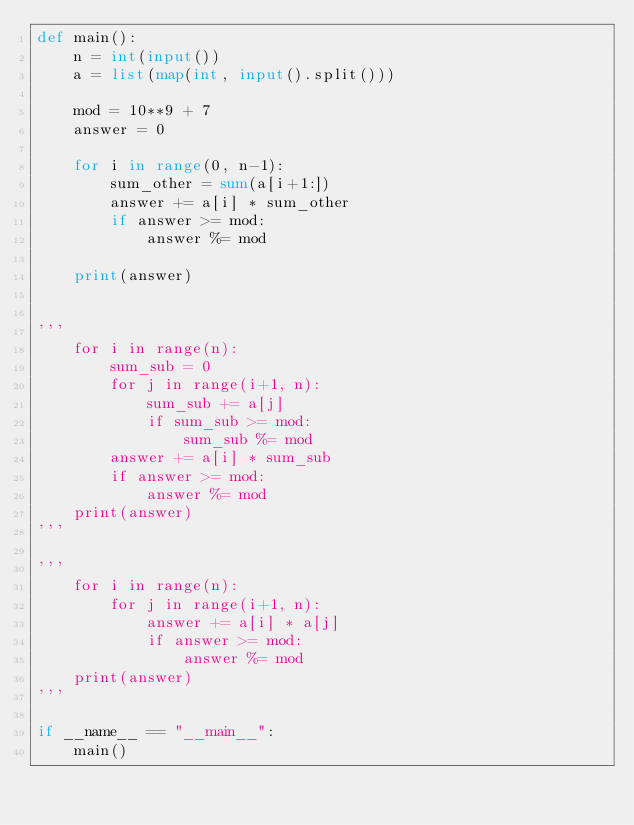Convert code to text. <code><loc_0><loc_0><loc_500><loc_500><_Python_>def main():
    n = int(input())
    a = list(map(int, input().split()))

    mod = 10**9 + 7
    answer = 0

    for i in range(0, n-1):
        sum_other = sum(a[i+1:])
        answer += a[i] * sum_other
        if answer >= mod:
            answer %= mod

    print(answer)


'''
    for i in range(n):
        sum_sub = 0
        for j in range(i+1, n):
            sum_sub += a[j]
            if sum_sub >= mod:
                sum_sub %= mod
        answer += a[i] * sum_sub
        if answer >= mod:
            answer %= mod
    print(answer)
'''

'''
    for i in range(n):
        for j in range(i+1, n):
            answer += a[i] * a[j]
            if answer >= mod:
                answer %= mod
    print(answer)
'''

if __name__ == "__main__":
    main()
</code> 